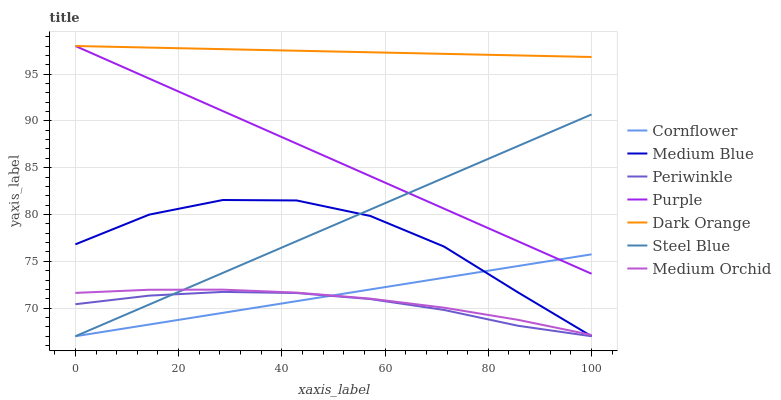Does Periwinkle have the minimum area under the curve?
Answer yes or no. Yes. Does Dark Orange have the maximum area under the curve?
Answer yes or no. Yes. Does Purple have the minimum area under the curve?
Answer yes or no. No. Does Purple have the maximum area under the curve?
Answer yes or no. No. Is Dark Orange the smoothest?
Answer yes or no. Yes. Is Medium Blue the roughest?
Answer yes or no. Yes. Is Purple the smoothest?
Answer yes or no. No. Is Purple the roughest?
Answer yes or no. No. Does Cornflower have the lowest value?
Answer yes or no. Yes. Does Purple have the lowest value?
Answer yes or no. No. Does Purple have the highest value?
Answer yes or no. Yes. Does Medium Orchid have the highest value?
Answer yes or no. No. Is Medium Blue less than Purple?
Answer yes or no. Yes. Is Medium Orchid greater than Periwinkle?
Answer yes or no. Yes. Does Steel Blue intersect Medium Blue?
Answer yes or no. Yes. Is Steel Blue less than Medium Blue?
Answer yes or no. No. Is Steel Blue greater than Medium Blue?
Answer yes or no. No. Does Medium Blue intersect Purple?
Answer yes or no. No. 